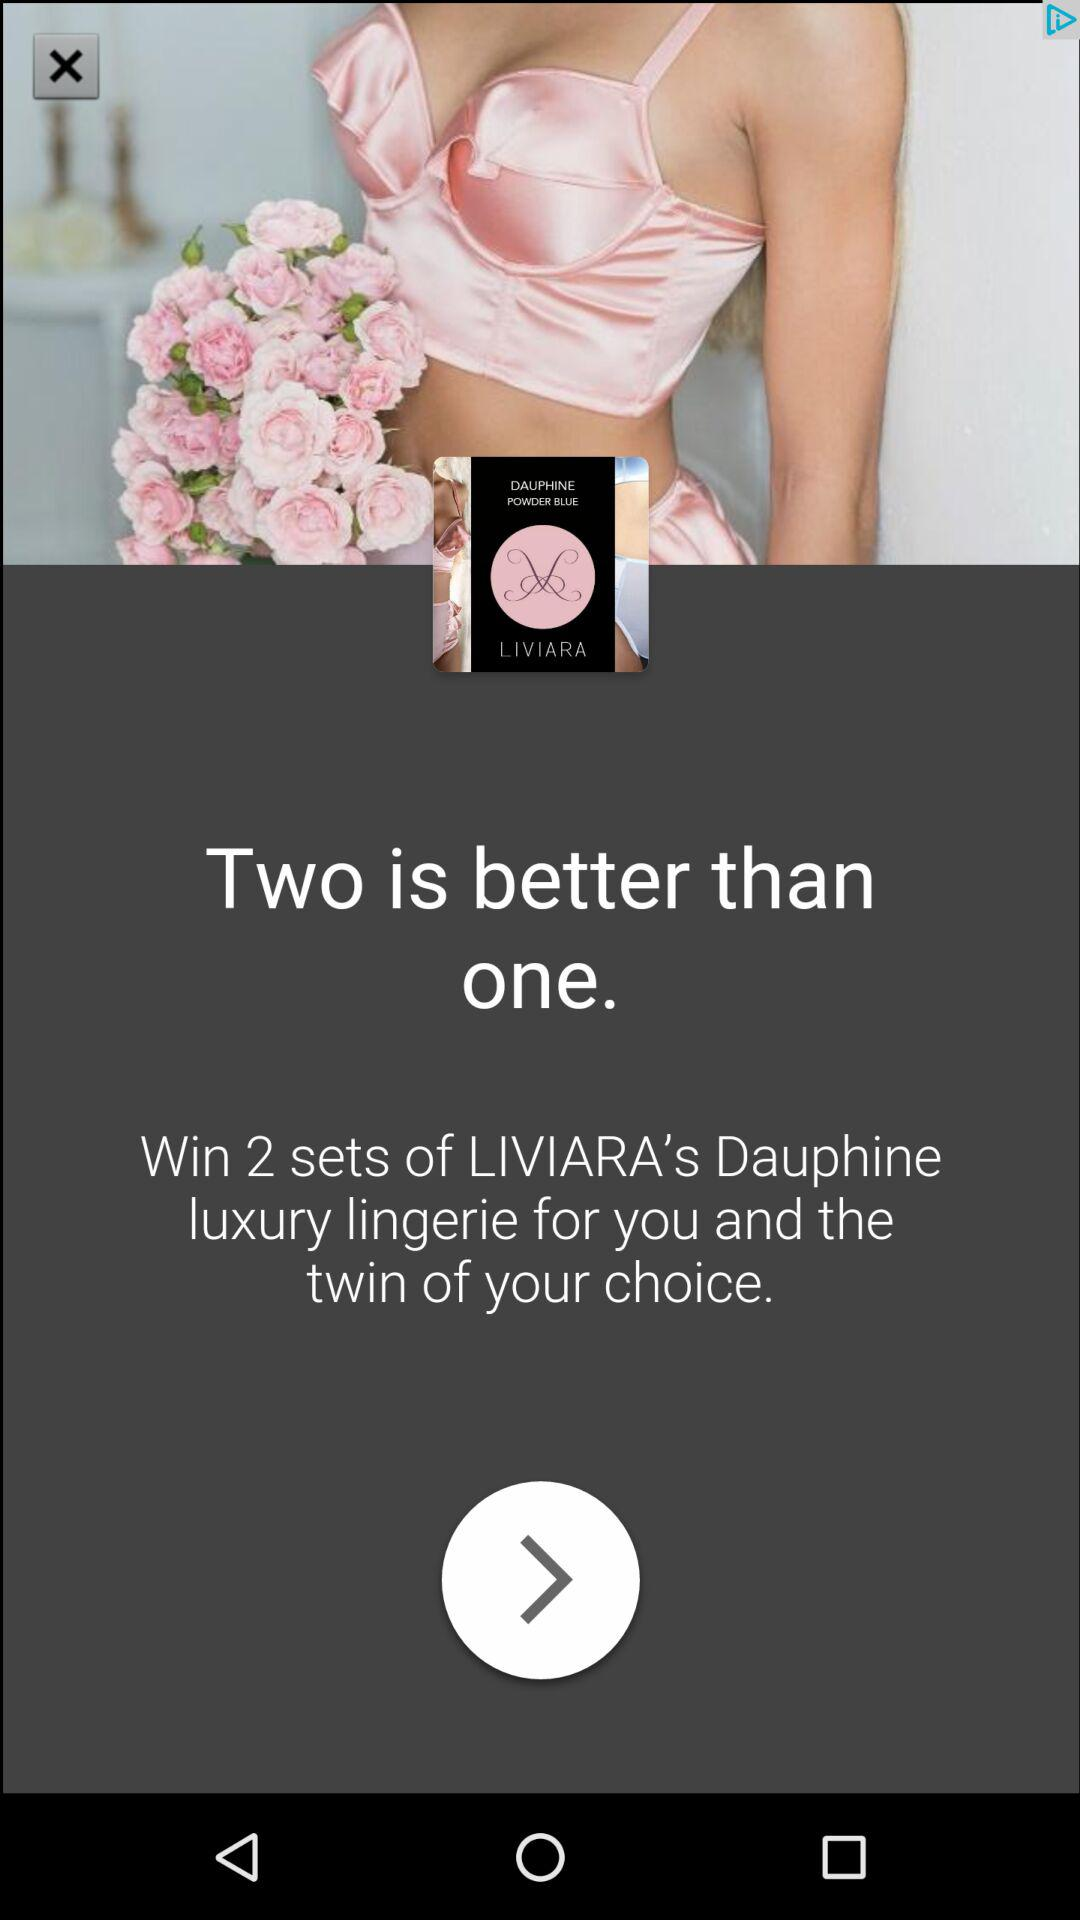How many more sets of lingerie can you win if you win this contest?
Answer the question using a single word or phrase. 2 